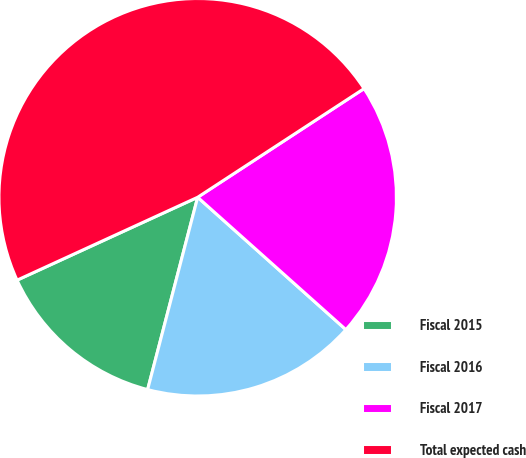<chart> <loc_0><loc_0><loc_500><loc_500><pie_chart><fcel>Fiscal 2015<fcel>Fiscal 2016<fcel>Fiscal 2017<fcel>Total expected cash<nl><fcel>14.1%<fcel>17.45%<fcel>20.81%<fcel>47.64%<nl></chart> 